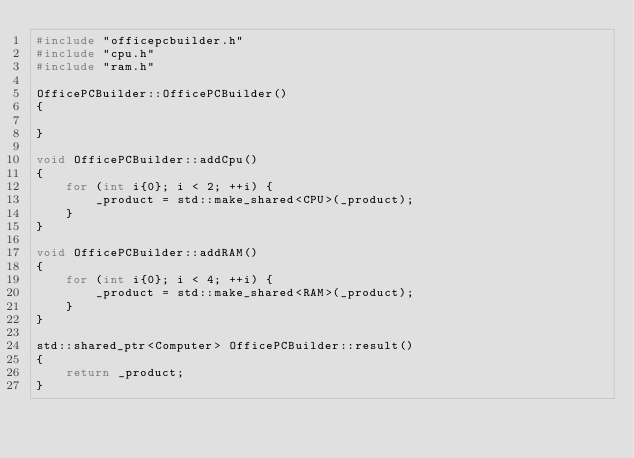<code> <loc_0><loc_0><loc_500><loc_500><_C++_>#include "officepcbuilder.h"
#include "cpu.h"
#include "ram.h"

OfficePCBuilder::OfficePCBuilder()
{

}

void OfficePCBuilder::addCpu()
{
    for (int i{0}; i < 2; ++i) {
        _product = std::make_shared<CPU>(_product);
    }
}

void OfficePCBuilder::addRAM()
{
    for (int i{0}; i < 4; ++i) {
        _product = std::make_shared<RAM>(_product);
    }
}

std::shared_ptr<Computer> OfficePCBuilder::result()
{
    return _product;
}
</code> 